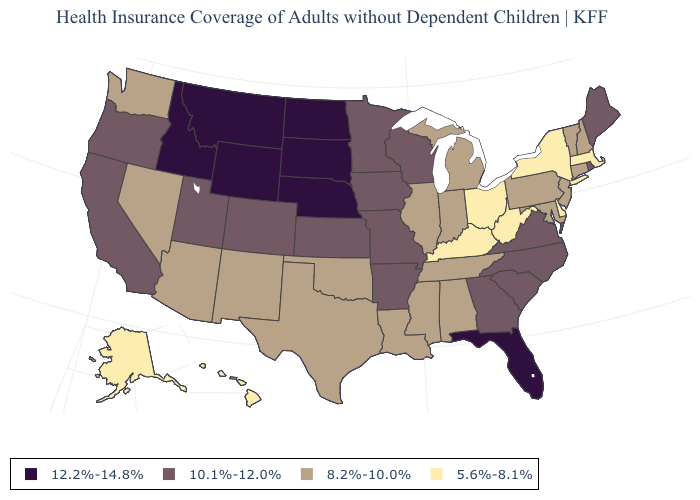Which states have the highest value in the USA?
Short answer required. Florida, Idaho, Montana, Nebraska, North Dakota, South Dakota, Wyoming. What is the value of Utah?
Concise answer only. 10.1%-12.0%. Does Alaska have the lowest value in the West?
Keep it brief. Yes. Among the states that border Minnesota , does Iowa have the highest value?
Answer briefly. No. What is the lowest value in the Northeast?
Answer briefly. 5.6%-8.1%. What is the value of Wyoming?
Write a very short answer. 12.2%-14.8%. What is the value of Alaska?
Quick response, please. 5.6%-8.1%. What is the value of Mississippi?
Short answer required. 8.2%-10.0%. What is the value of Kansas?
Write a very short answer. 10.1%-12.0%. Among the states that border Colorado , which have the highest value?
Be succinct. Nebraska, Wyoming. Among the states that border Ohio , which have the highest value?
Be succinct. Indiana, Michigan, Pennsylvania. Among the states that border Colorado , does Arizona have the highest value?
Write a very short answer. No. Does Connecticut have the lowest value in the USA?
Be succinct. No. 